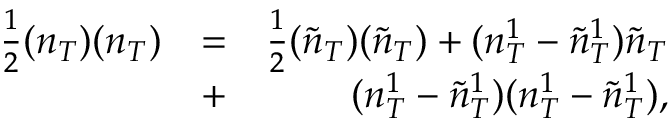<formula> <loc_0><loc_0><loc_500><loc_500>\begin{array} { r l r } { \frac { 1 } { 2 } ( n _ { T } ) ( n _ { T } ) } & { = } & { \frac { 1 } { 2 } ( \tilde { n } _ { T } ) ( \tilde { n } _ { T } ) + ( n _ { T } ^ { 1 } - \tilde { n } _ { T } ^ { 1 } ) \tilde { n } _ { T } } \\ & { + } & { ( n _ { T } ^ { 1 } - \tilde { n } _ { T } ^ { 1 } ) ( n _ { T } ^ { 1 } - \tilde { n } _ { T } ^ { 1 } ) , } \end{array}</formula> 